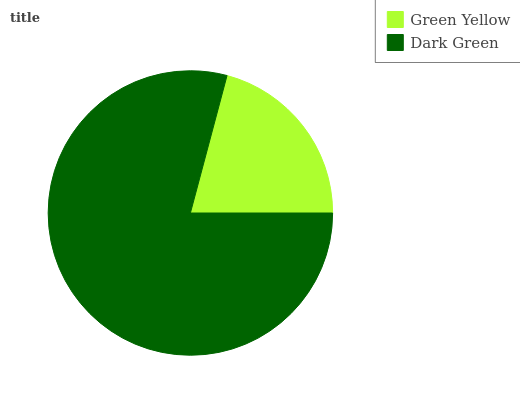Is Green Yellow the minimum?
Answer yes or no. Yes. Is Dark Green the maximum?
Answer yes or no. Yes. Is Dark Green the minimum?
Answer yes or no. No. Is Dark Green greater than Green Yellow?
Answer yes or no. Yes. Is Green Yellow less than Dark Green?
Answer yes or no. Yes. Is Green Yellow greater than Dark Green?
Answer yes or no. No. Is Dark Green less than Green Yellow?
Answer yes or no. No. Is Dark Green the high median?
Answer yes or no. Yes. Is Green Yellow the low median?
Answer yes or no. Yes. Is Green Yellow the high median?
Answer yes or no. No. Is Dark Green the low median?
Answer yes or no. No. 